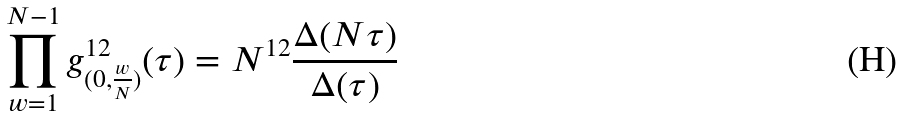Convert formula to latex. <formula><loc_0><loc_0><loc_500><loc_500>\prod _ { w = 1 } ^ { N - 1 } g _ { ( 0 , \frac { w } { N } ) } ^ { 1 2 } ( \tau ) = N ^ { 1 2 } \frac { \Delta ( N \tau ) } { \Delta ( \tau ) }</formula> 